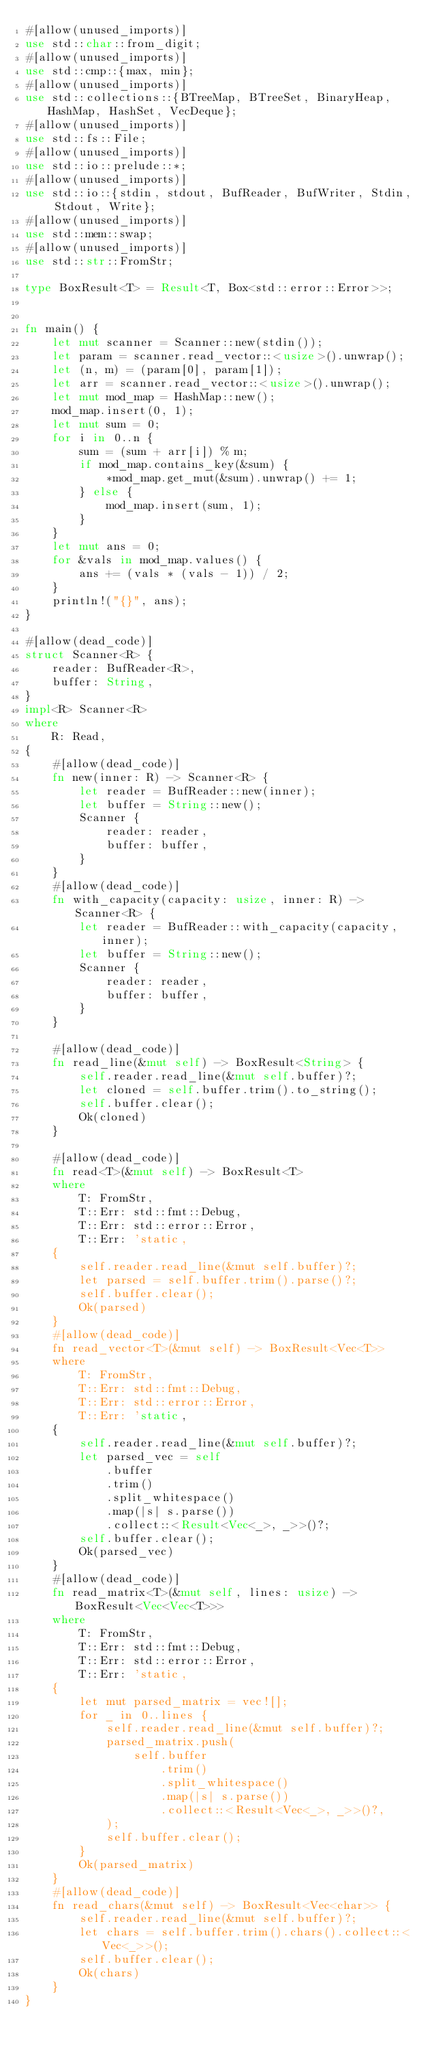<code> <loc_0><loc_0><loc_500><loc_500><_Rust_>#[allow(unused_imports)]
use std::char::from_digit;
#[allow(unused_imports)]
use std::cmp::{max, min};
#[allow(unused_imports)]
use std::collections::{BTreeMap, BTreeSet, BinaryHeap, HashMap, HashSet, VecDeque};
#[allow(unused_imports)]
use std::fs::File;
#[allow(unused_imports)]
use std::io::prelude::*;
#[allow(unused_imports)]
use std::io::{stdin, stdout, BufReader, BufWriter, Stdin, Stdout, Write};
#[allow(unused_imports)]
use std::mem::swap;
#[allow(unused_imports)]
use std::str::FromStr;

type BoxResult<T> = Result<T, Box<std::error::Error>>;


fn main() {
    let mut scanner = Scanner::new(stdin());
    let param = scanner.read_vector::<usize>().unwrap();
    let (n, m) = (param[0], param[1]);
    let arr = scanner.read_vector::<usize>().unwrap();
    let mut mod_map = HashMap::new();
    mod_map.insert(0, 1);
    let mut sum = 0;
    for i in 0..n {
        sum = (sum + arr[i]) % m;
        if mod_map.contains_key(&sum) {
            *mod_map.get_mut(&sum).unwrap() += 1;
        } else {
            mod_map.insert(sum, 1);
        }
    }
    let mut ans = 0;
    for &vals in mod_map.values() {
        ans += (vals * (vals - 1)) / 2;
    }
    println!("{}", ans);
}

#[allow(dead_code)]
struct Scanner<R> {
    reader: BufReader<R>,
    buffer: String,
}
impl<R> Scanner<R>
where
    R: Read,
{
    #[allow(dead_code)]
    fn new(inner: R) -> Scanner<R> {
        let reader = BufReader::new(inner);
        let buffer = String::new();
        Scanner {
            reader: reader,
            buffer: buffer,
        }
    }
    #[allow(dead_code)]
    fn with_capacity(capacity: usize, inner: R) -> Scanner<R> {
        let reader = BufReader::with_capacity(capacity, inner);
        let buffer = String::new();
        Scanner {
            reader: reader,
            buffer: buffer,
        }
    }

    #[allow(dead_code)]
    fn read_line(&mut self) -> BoxResult<String> {
        self.reader.read_line(&mut self.buffer)?;
        let cloned = self.buffer.trim().to_string();
        self.buffer.clear();
        Ok(cloned)
    }

    #[allow(dead_code)]
    fn read<T>(&mut self) -> BoxResult<T>
    where
        T: FromStr,
        T::Err: std::fmt::Debug,
        T::Err: std::error::Error,
        T::Err: 'static,
    {
        self.reader.read_line(&mut self.buffer)?;
        let parsed = self.buffer.trim().parse()?;
        self.buffer.clear();
        Ok(parsed)
    }
    #[allow(dead_code)]
    fn read_vector<T>(&mut self) -> BoxResult<Vec<T>>
    where
        T: FromStr,
        T::Err: std::fmt::Debug,
        T::Err: std::error::Error,
        T::Err: 'static,
    {
        self.reader.read_line(&mut self.buffer)?;
        let parsed_vec = self
            .buffer
            .trim()
            .split_whitespace()
            .map(|s| s.parse())
            .collect::<Result<Vec<_>, _>>()?;
        self.buffer.clear();
        Ok(parsed_vec)
    }
    #[allow(dead_code)]
    fn read_matrix<T>(&mut self, lines: usize) -> BoxResult<Vec<Vec<T>>>
    where
        T: FromStr,
        T::Err: std::fmt::Debug,
        T::Err: std::error::Error,
        T::Err: 'static,
    {
        let mut parsed_matrix = vec![];
        for _ in 0..lines {
            self.reader.read_line(&mut self.buffer)?;
            parsed_matrix.push(
                self.buffer
                    .trim()
                    .split_whitespace()
                    .map(|s| s.parse())
                    .collect::<Result<Vec<_>, _>>()?,
            );
            self.buffer.clear();
        }
        Ok(parsed_matrix)
    }
    #[allow(dead_code)]
    fn read_chars(&mut self) -> BoxResult<Vec<char>> {
        self.reader.read_line(&mut self.buffer)?;
        let chars = self.buffer.trim().chars().collect::<Vec<_>>();
        self.buffer.clear();
        Ok(chars)
    }
}
</code> 